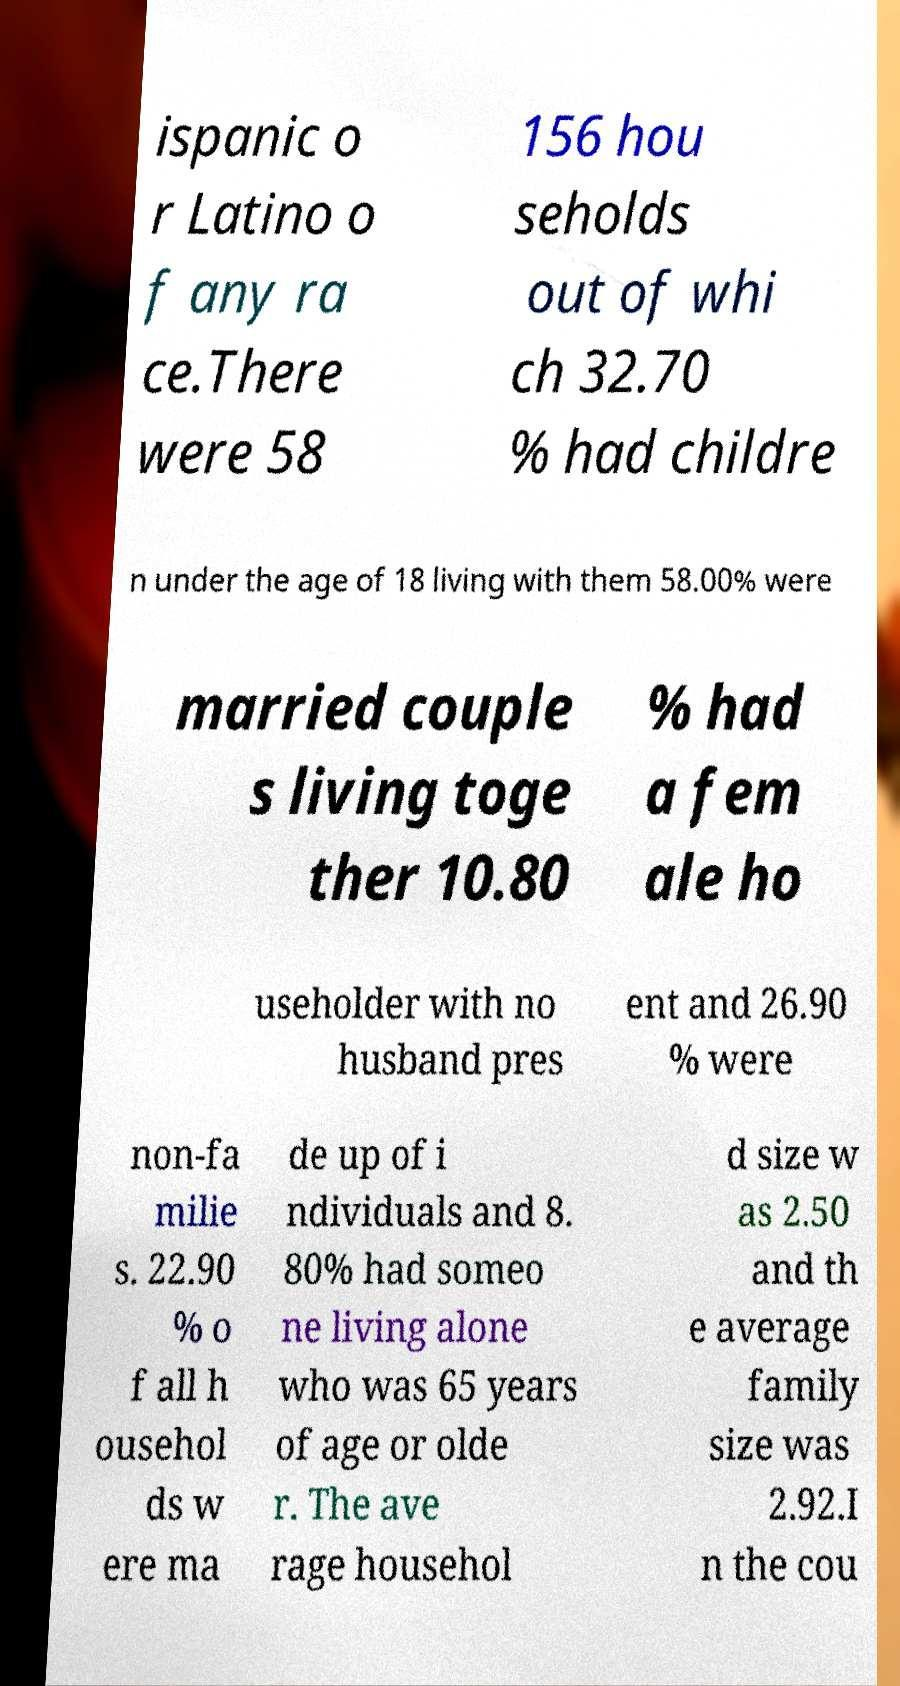Please read and relay the text visible in this image. What does it say? ispanic o r Latino o f any ra ce.There were 58 156 hou seholds out of whi ch 32.70 % had childre n under the age of 18 living with them 58.00% were married couple s living toge ther 10.80 % had a fem ale ho useholder with no husband pres ent and 26.90 % were non-fa milie s. 22.90 % o f all h ousehol ds w ere ma de up of i ndividuals and 8. 80% had someo ne living alone who was 65 years of age or olde r. The ave rage househol d size w as 2.50 and th e average family size was 2.92.I n the cou 